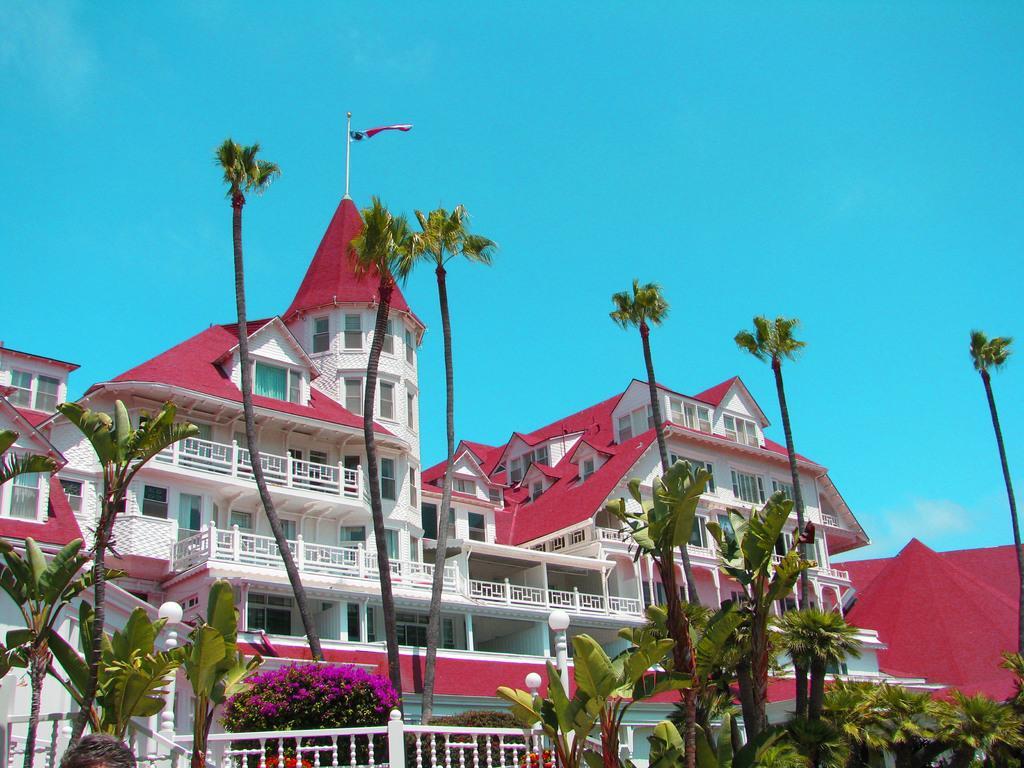Could you give a brief overview of what you see in this image? At the bottom of the picture, we see plants and an iron railing. Behind that, we see a plant with pink color flowers. Behind that, we see a building in white and red color. At the top of the building, we see a flag in red and blue color. There are many trees. At the top of the picture, we see the sky, which is blue in color. 